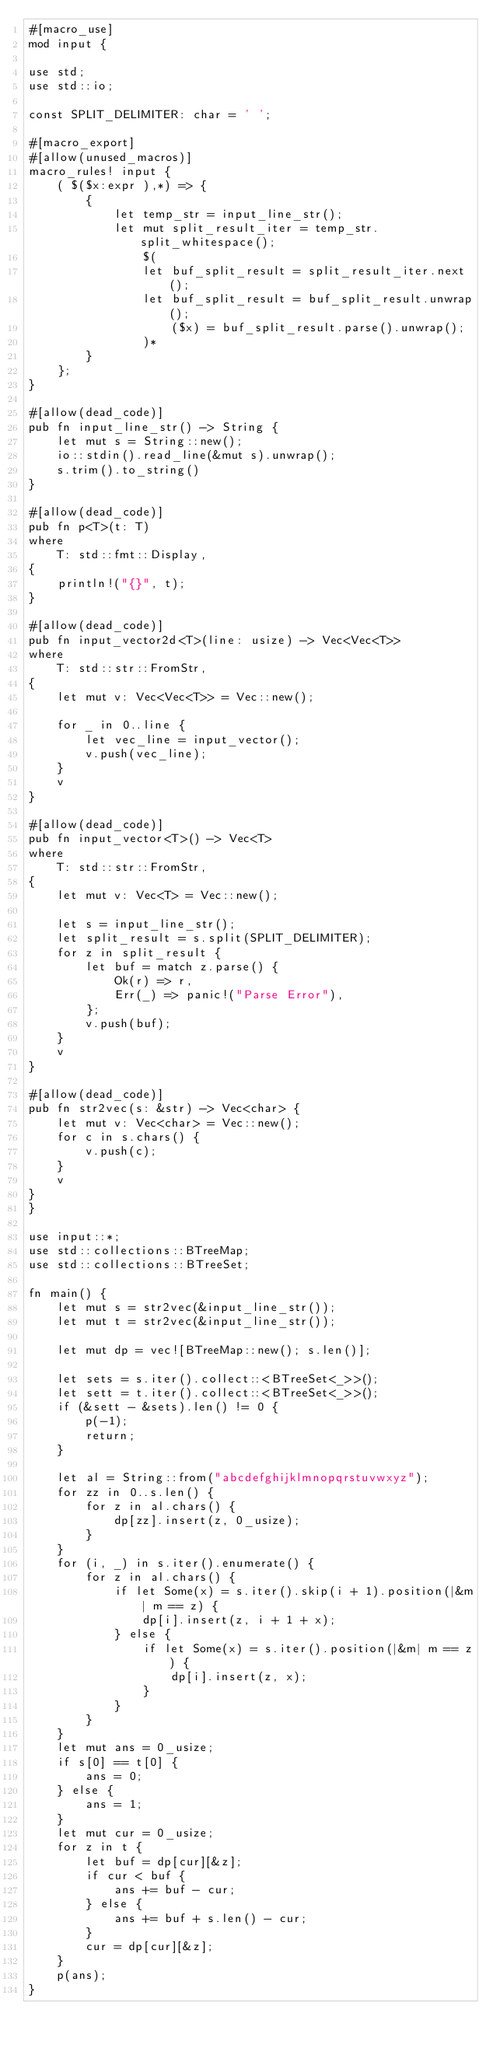<code> <loc_0><loc_0><loc_500><loc_500><_Rust_>#[macro_use]
mod input {

use std;
use std::io;

const SPLIT_DELIMITER: char = ' ';

#[macro_export]
#[allow(unused_macros)]
macro_rules! input {
    ( $($x:expr ),*) => {
        {
            let temp_str = input_line_str();
            let mut split_result_iter = temp_str.split_whitespace();
                $(
                let buf_split_result = split_result_iter.next();
                let buf_split_result = buf_split_result.unwrap();
                    ($x) = buf_split_result.parse().unwrap();
                )*
        }
    };
}

#[allow(dead_code)]
pub fn input_line_str() -> String {
    let mut s = String::new();
    io::stdin().read_line(&mut s).unwrap();
    s.trim().to_string()
}

#[allow(dead_code)]
pub fn p<T>(t: T)
where
    T: std::fmt::Display,
{
    println!("{}", t);
}

#[allow(dead_code)]
pub fn input_vector2d<T>(line: usize) -> Vec<Vec<T>>
where
    T: std::str::FromStr,
{
    let mut v: Vec<Vec<T>> = Vec::new();

    for _ in 0..line {
        let vec_line = input_vector();
        v.push(vec_line);
    }
    v
}

#[allow(dead_code)]
pub fn input_vector<T>() -> Vec<T>
where
    T: std::str::FromStr,
{
    let mut v: Vec<T> = Vec::new();

    let s = input_line_str();
    let split_result = s.split(SPLIT_DELIMITER);
    for z in split_result {
        let buf = match z.parse() {
            Ok(r) => r,
            Err(_) => panic!("Parse Error"),
        };
        v.push(buf);
    }
    v
}

#[allow(dead_code)]
pub fn str2vec(s: &str) -> Vec<char> {
    let mut v: Vec<char> = Vec::new();
    for c in s.chars() {
        v.push(c);
    }
    v
}
}

use input::*;
use std::collections::BTreeMap;
use std::collections::BTreeSet;

fn main() {
    let mut s = str2vec(&input_line_str());
    let mut t = str2vec(&input_line_str());

    let mut dp = vec![BTreeMap::new(); s.len()];

    let sets = s.iter().collect::<BTreeSet<_>>();
    let sett = t.iter().collect::<BTreeSet<_>>();
    if (&sett - &sets).len() != 0 {
        p(-1);
        return;
    }

    let al = String::from("abcdefghijklmnopqrstuvwxyz");
    for zz in 0..s.len() {
        for z in al.chars() {
            dp[zz].insert(z, 0_usize);
        }
    }
    for (i, _) in s.iter().enumerate() {
        for z in al.chars() {
            if let Some(x) = s.iter().skip(i + 1).position(|&m| m == z) {
                dp[i].insert(z, i + 1 + x);
            } else {
                if let Some(x) = s.iter().position(|&m| m == z) {
                    dp[i].insert(z, x);
                }
            }
        }
    }
    let mut ans = 0_usize;
    if s[0] == t[0] {
        ans = 0;
    } else {
        ans = 1;
    }
    let mut cur = 0_usize;
    for z in t {
        let buf = dp[cur][&z];
        if cur < buf {
            ans += buf - cur;
        } else {
            ans += buf + s.len() - cur;
        }
        cur = dp[cur][&z];
    }
    p(ans);
}</code> 